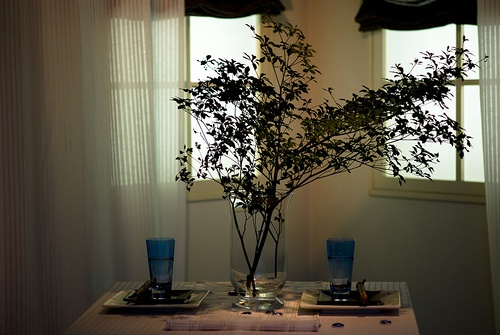Describe the objects in this image and their specific colors. I can see dining table in black, gray, and maroon tones, vase in black and gray tones, cup in black, darkblue, gray, and purple tones, and cup in black and gray tones in this image. 